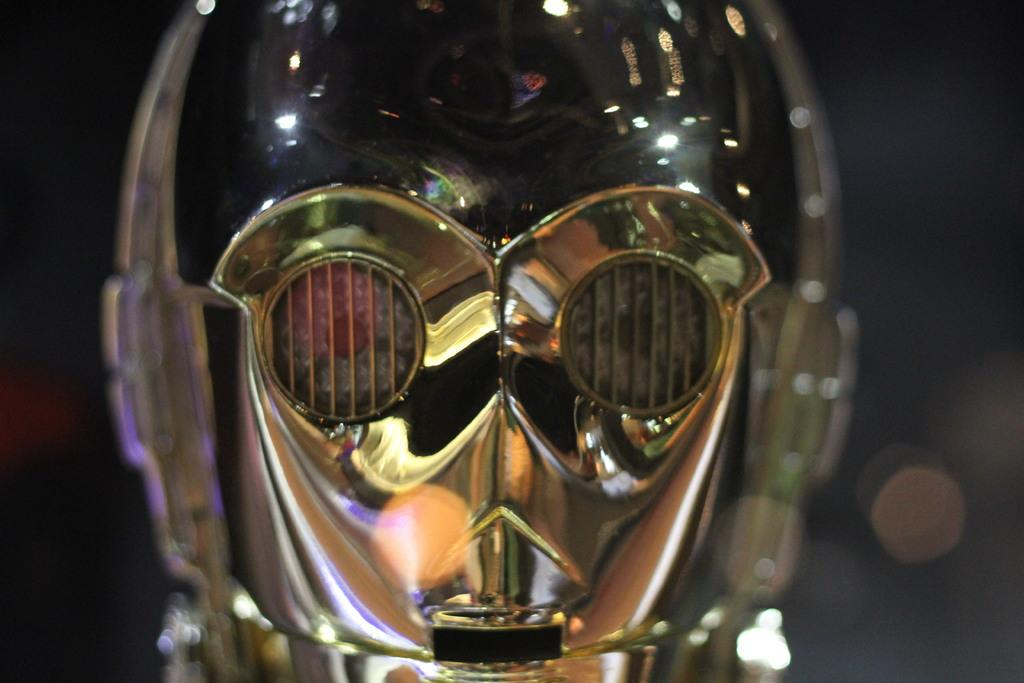What type of object can be seen in the image? There is a metallic object in the image. Can you describe the background of the image? The background of the image is blurred. How many women are present in the image? There is no mention of women in the provided facts, so we cannot determine the number of women in the image. 